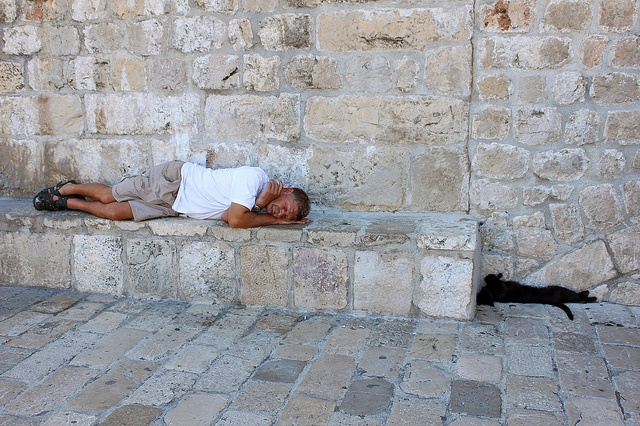Describe the objects in this image and their specific colors. I can see people in darkgray, lavender, brown, and black tones and cat in darkgray, black, and gray tones in this image. 